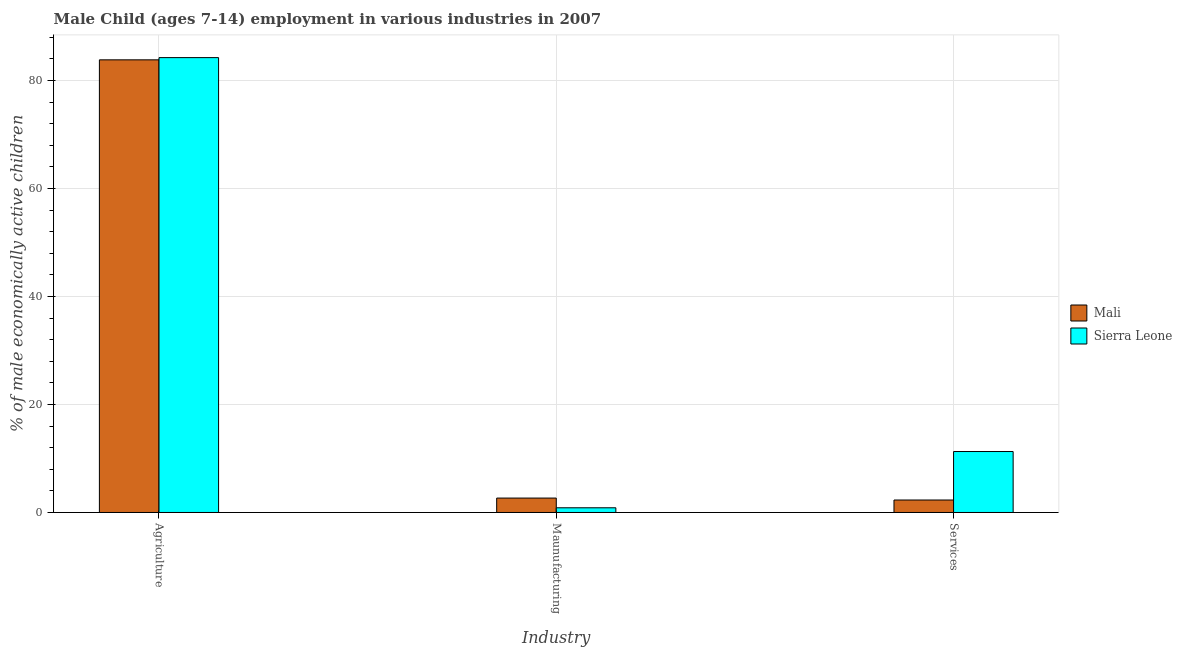Are the number of bars per tick equal to the number of legend labels?
Offer a terse response. Yes. Are the number of bars on each tick of the X-axis equal?
Provide a short and direct response. Yes. How many bars are there on the 3rd tick from the left?
Your answer should be very brief. 2. How many bars are there on the 2nd tick from the right?
Ensure brevity in your answer.  2. What is the label of the 2nd group of bars from the left?
Provide a succinct answer. Maunufacturing. What is the percentage of economically active children in agriculture in Sierra Leone?
Keep it short and to the point. 84.24. Across all countries, what is the maximum percentage of economically active children in agriculture?
Provide a succinct answer. 84.24. Across all countries, what is the minimum percentage of economically active children in manufacturing?
Offer a very short reply. 0.87. In which country was the percentage of economically active children in agriculture maximum?
Offer a very short reply. Sierra Leone. In which country was the percentage of economically active children in manufacturing minimum?
Ensure brevity in your answer.  Sierra Leone. What is the total percentage of economically active children in agriculture in the graph?
Ensure brevity in your answer.  168.07. What is the difference between the percentage of economically active children in agriculture in Sierra Leone and that in Mali?
Give a very brief answer. 0.41. What is the difference between the percentage of economically active children in agriculture in Sierra Leone and the percentage of economically active children in manufacturing in Mali?
Keep it short and to the point. 81.57. What is the average percentage of economically active children in manufacturing per country?
Offer a terse response. 1.77. What is the difference between the percentage of economically active children in agriculture and percentage of economically active children in manufacturing in Sierra Leone?
Offer a very short reply. 83.37. In how many countries, is the percentage of economically active children in agriculture greater than 52 %?
Your answer should be very brief. 2. What is the ratio of the percentage of economically active children in manufacturing in Mali to that in Sierra Leone?
Provide a short and direct response. 3.07. Is the percentage of economically active children in services in Mali less than that in Sierra Leone?
Offer a very short reply. Yes. Is the difference between the percentage of economically active children in services in Mali and Sierra Leone greater than the difference between the percentage of economically active children in manufacturing in Mali and Sierra Leone?
Make the answer very short. No. What is the difference between the highest and the second highest percentage of economically active children in agriculture?
Your answer should be compact. 0.41. What is the difference between the highest and the lowest percentage of economically active children in manufacturing?
Provide a short and direct response. 1.8. What does the 2nd bar from the left in Services represents?
Your answer should be very brief. Sierra Leone. What does the 2nd bar from the right in Maunufacturing represents?
Offer a terse response. Mali. Is it the case that in every country, the sum of the percentage of economically active children in agriculture and percentage of economically active children in manufacturing is greater than the percentage of economically active children in services?
Your answer should be very brief. Yes. How many bars are there?
Ensure brevity in your answer.  6. Does the graph contain any zero values?
Make the answer very short. No. Does the graph contain grids?
Offer a very short reply. Yes. How many legend labels are there?
Your answer should be very brief. 2. How are the legend labels stacked?
Give a very brief answer. Vertical. What is the title of the graph?
Keep it short and to the point. Male Child (ages 7-14) employment in various industries in 2007. Does "Seychelles" appear as one of the legend labels in the graph?
Give a very brief answer. No. What is the label or title of the X-axis?
Provide a succinct answer. Industry. What is the label or title of the Y-axis?
Offer a terse response. % of male economically active children. What is the % of male economically active children of Mali in Agriculture?
Ensure brevity in your answer.  83.83. What is the % of male economically active children of Sierra Leone in Agriculture?
Ensure brevity in your answer.  84.24. What is the % of male economically active children in Mali in Maunufacturing?
Your answer should be very brief. 2.67. What is the % of male economically active children in Sierra Leone in Maunufacturing?
Offer a terse response. 0.87. What is the % of male economically active children in Mali in Services?
Your response must be concise. 2.31. What is the % of male economically active children of Sierra Leone in Services?
Make the answer very short. 11.29. Across all Industry, what is the maximum % of male economically active children of Mali?
Offer a very short reply. 83.83. Across all Industry, what is the maximum % of male economically active children of Sierra Leone?
Give a very brief answer. 84.24. Across all Industry, what is the minimum % of male economically active children in Mali?
Provide a short and direct response. 2.31. Across all Industry, what is the minimum % of male economically active children in Sierra Leone?
Keep it short and to the point. 0.87. What is the total % of male economically active children of Mali in the graph?
Ensure brevity in your answer.  88.81. What is the total % of male economically active children in Sierra Leone in the graph?
Provide a succinct answer. 96.4. What is the difference between the % of male economically active children in Mali in Agriculture and that in Maunufacturing?
Your answer should be compact. 81.16. What is the difference between the % of male economically active children of Sierra Leone in Agriculture and that in Maunufacturing?
Provide a short and direct response. 83.37. What is the difference between the % of male economically active children of Mali in Agriculture and that in Services?
Give a very brief answer. 81.52. What is the difference between the % of male economically active children in Sierra Leone in Agriculture and that in Services?
Provide a succinct answer. 72.95. What is the difference between the % of male economically active children in Mali in Maunufacturing and that in Services?
Your response must be concise. 0.36. What is the difference between the % of male economically active children of Sierra Leone in Maunufacturing and that in Services?
Make the answer very short. -10.42. What is the difference between the % of male economically active children in Mali in Agriculture and the % of male economically active children in Sierra Leone in Maunufacturing?
Offer a very short reply. 82.96. What is the difference between the % of male economically active children in Mali in Agriculture and the % of male economically active children in Sierra Leone in Services?
Ensure brevity in your answer.  72.54. What is the difference between the % of male economically active children in Mali in Maunufacturing and the % of male economically active children in Sierra Leone in Services?
Provide a short and direct response. -8.62. What is the average % of male economically active children in Mali per Industry?
Provide a succinct answer. 29.6. What is the average % of male economically active children in Sierra Leone per Industry?
Offer a very short reply. 32.13. What is the difference between the % of male economically active children of Mali and % of male economically active children of Sierra Leone in Agriculture?
Keep it short and to the point. -0.41. What is the difference between the % of male economically active children of Mali and % of male economically active children of Sierra Leone in Services?
Provide a succinct answer. -8.98. What is the ratio of the % of male economically active children in Mali in Agriculture to that in Maunufacturing?
Provide a succinct answer. 31.4. What is the ratio of the % of male economically active children in Sierra Leone in Agriculture to that in Maunufacturing?
Give a very brief answer. 96.83. What is the ratio of the % of male economically active children in Mali in Agriculture to that in Services?
Your answer should be very brief. 36.29. What is the ratio of the % of male economically active children in Sierra Leone in Agriculture to that in Services?
Your response must be concise. 7.46. What is the ratio of the % of male economically active children of Mali in Maunufacturing to that in Services?
Offer a very short reply. 1.16. What is the ratio of the % of male economically active children in Sierra Leone in Maunufacturing to that in Services?
Your response must be concise. 0.08. What is the difference between the highest and the second highest % of male economically active children of Mali?
Ensure brevity in your answer.  81.16. What is the difference between the highest and the second highest % of male economically active children of Sierra Leone?
Your response must be concise. 72.95. What is the difference between the highest and the lowest % of male economically active children of Mali?
Offer a terse response. 81.52. What is the difference between the highest and the lowest % of male economically active children of Sierra Leone?
Your answer should be compact. 83.37. 